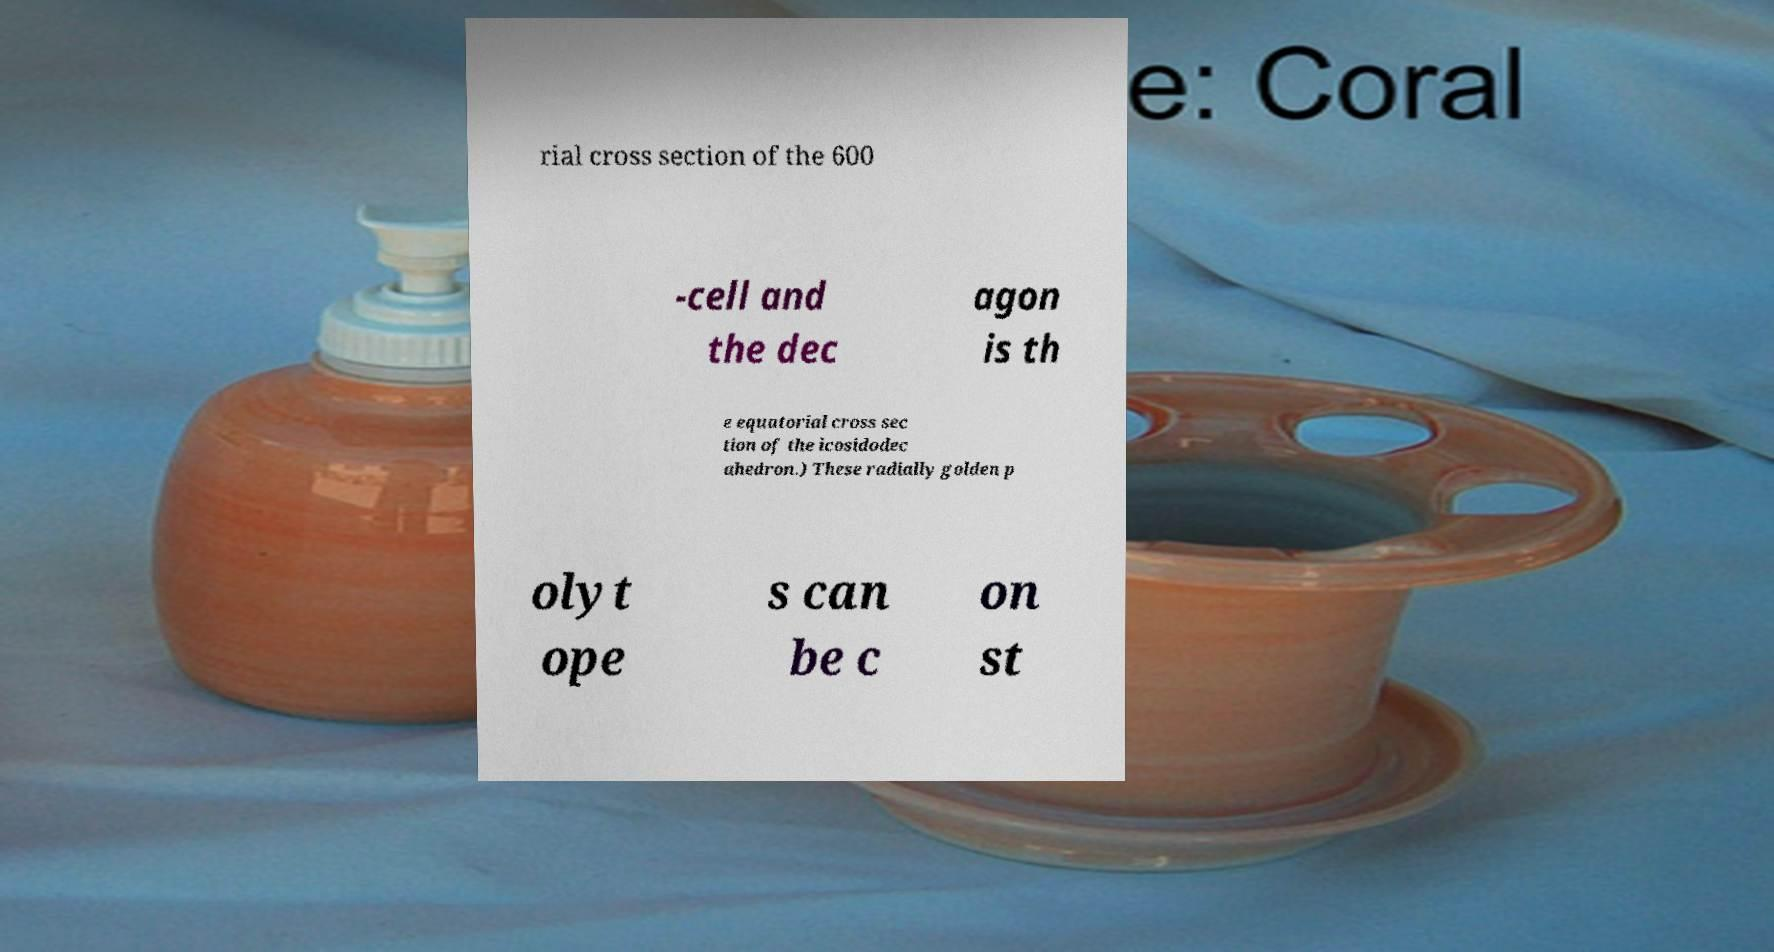Can you read and provide the text displayed in the image?This photo seems to have some interesting text. Can you extract and type it out for me? rial cross section of the 600 -cell and the dec agon is th e equatorial cross sec tion of the icosidodec ahedron.) These radially golden p olyt ope s can be c on st 